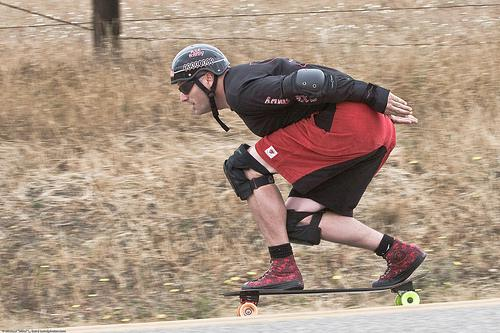Question: what is the man doing?
Choices:
A. Painting.
B. Rowing.
C. Skateboarding.
D. Resting.
Answer with the letter. Answer: C Question: what is the color of the man's helmet?
Choices:
A. Blue.
B. Green.
C. Silver.
D. Black.
Answer with the letter. Answer: D Question: where is the man?
Choices:
A. On the road.
B. In the field.
C. In the forest.
D. In the meadow.
Answer with the letter. Answer: A Question: why the man is wearing a helmet?
Choices:
A. To protect his head.
B. For safety purposes.
C. As a disguise.
D. To keep warm.
Answer with the letter. Answer: B Question: who is skateboarding?
Choices:
A. A boy.
B. A child.
C. A dog.
D. A man.
Answer with the letter. Answer: D 